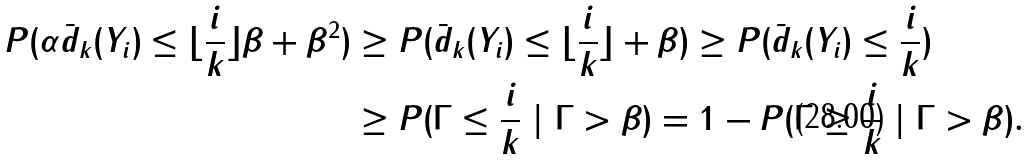Convert formula to latex. <formula><loc_0><loc_0><loc_500><loc_500>P ( \alpha \bar { d } _ { k } ( Y _ { i } ) \leq \lfloor \frac { i } { k } \rfloor \beta + \beta ^ { 2 } ) & \geq P ( \bar { d } _ { k } ( Y _ { i } ) \leq \lfloor \frac { i } { k } \rfloor + \beta ) \geq P ( \bar { d } _ { k } ( Y _ { i } ) \leq \frac { i } { k } ) \\ & \geq P ( \Gamma \leq \frac { i } { k } \ | \ \Gamma > \beta ) = 1 - P ( \Gamma \geq \frac { i } { k } \ | \ \Gamma > \beta ) .</formula> 